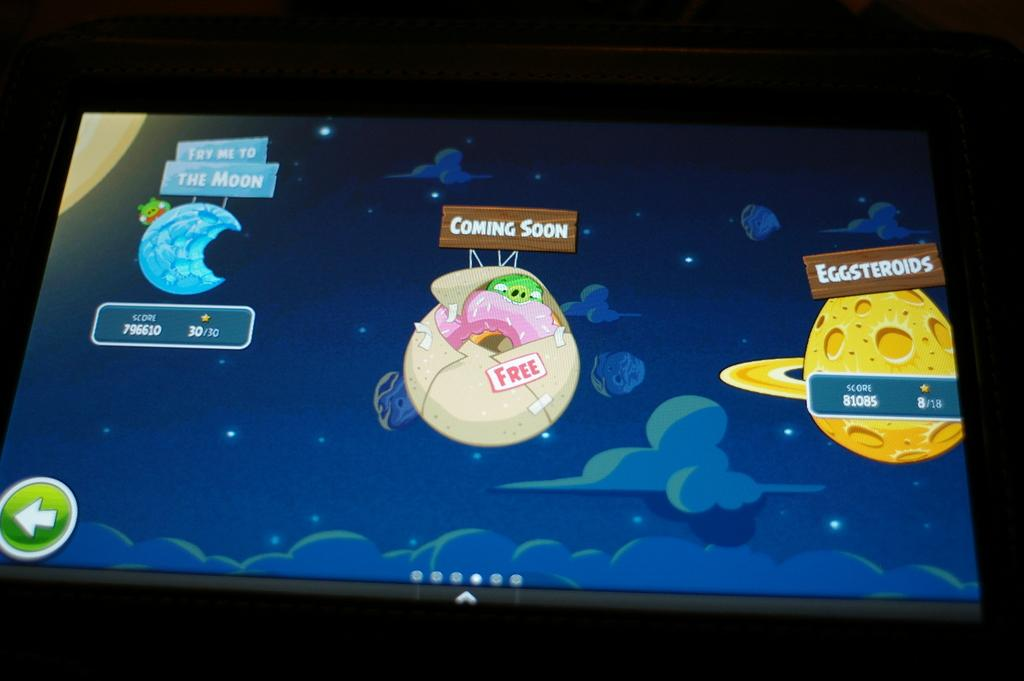What is the main object in the image? There is a screen in the image. What is being displayed on the screen? The screen displays cartoon images. Can you describe the colors of the cartoon images? The cartoon images are in yellow, cream, and blue colors. What else can be seen in the image besides the screen? There is a background visible in the image. Are there any fangs visible on the cartoon characters in the image? There are no fangs visible on the cartoon characters in the image, as the provided facts do not mention any such details. 